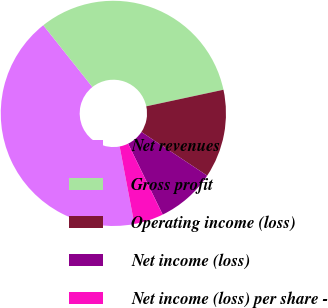Convert chart. <chart><loc_0><loc_0><loc_500><loc_500><pie_chart><fcel>Net revenues<fcel>Gross profit<fcel>Operating income (loss)<fcel>Net income (loss)<fcel>Net income (loss) per share -<nl><fcel>42.3%<fcel>32.32%<fcel>12.69%<fcel>8.46%<fcel>4.23%<nl></chart> 